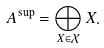<formula> <loc_0><loc_0><loc_500><loc_500>A ^ { \sup } = \bigoplus _ { X \in \mathcal { X } } X .</formula> 